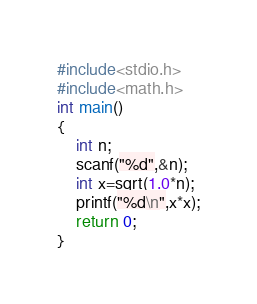Convert code to text. <code><loc_0><loc_0><loc_500><loc_500><_C_>#include<stdio.h>
#include<math.h>
int main()
{
    int n;
    scanf("%d",&n);
    int x=sqrt(1.0*n);
    printf("%d\n",x*x);
    return 0;
}</code> 